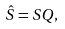Convert formula to latex. <formula><loc_0><loc_0><loc_500><loc_500>\hat { S } = S Q ,</formula> 